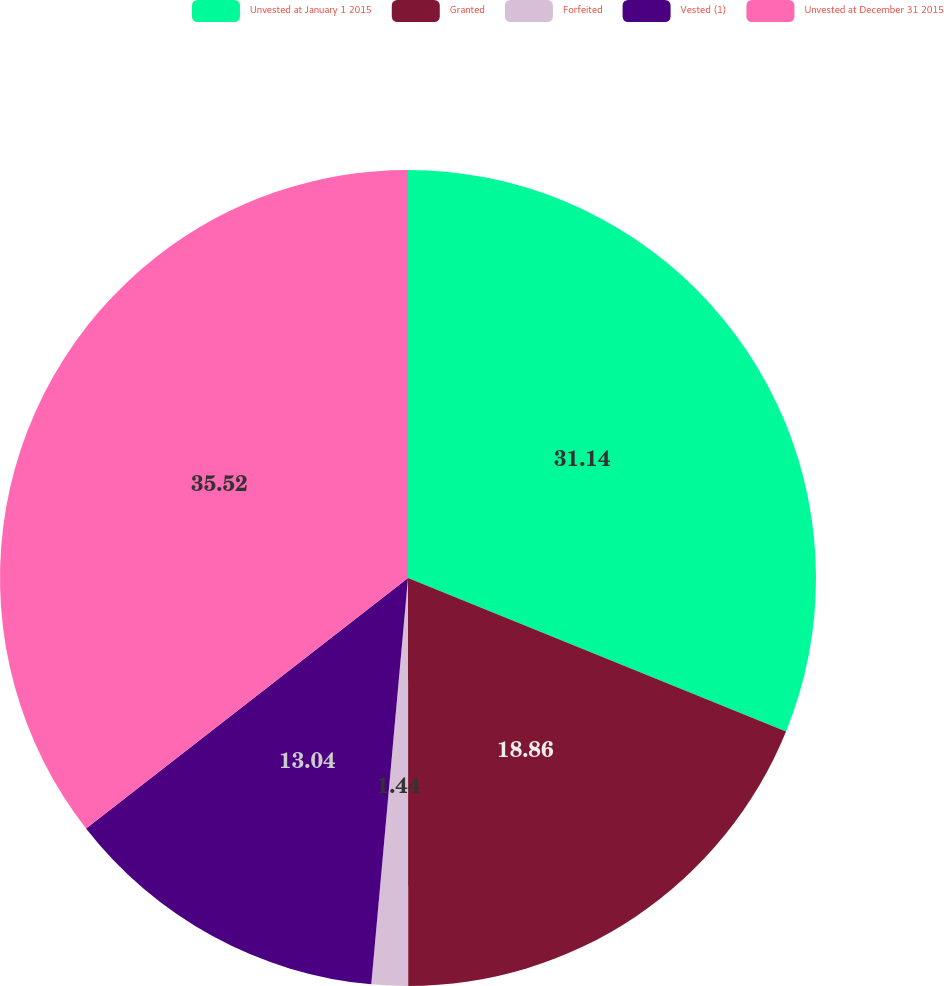<chart> <loc_0><loc_0><loc_500><loc_500><pie_chart><fcel>Unvested at January 1 2015<fcel>Granted<fcel>Forfeited<fcel>Vested (1)<fcel>Unvested at December 31 2015<nl><fcel>31.14%<fcel>18.86%<fcel>1.44%<fcel>13.04%<fcel>35.53%<nl></chart> 